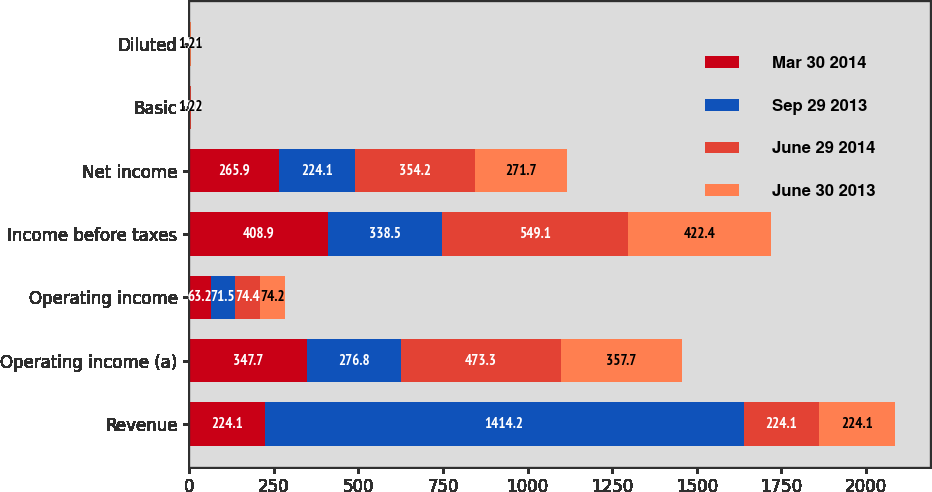<chart> <loc_0><loc_0><loc_500><loc_500><stacked_bar_chart><ecel><fcel>Revenue<fcel>Operating income (a)<fcel>Operating income<fcel>Income before taxes<fcel>Net income<fcel>Basic<fcel>Diluted<nl><fcel>Mar 30 2014<fcel>224.1<fcel>347.7<fcel>63.2<fcel>408.9<fcel>265.9<fcel>1.21<fcel>1.21<nl><fcel>Sep 29 2013<fcel>1414.2<fcel>276.8<fcel>71.5<fcel>338.5<fcel>224.1<fcel>1<fcel>0.99<nl><fcel>June 29 2014<fcel>224.1<fcel>473.3<fcel>74.4<fcel>549.1<fcel>354.2<fcel>1.63<fcel>1.62<nl><fcel>June 30 2013<fcel>224.1<fcel>357.7<fcel>74.2<fcel>422.4<fcel>271.7<fcel>1.22<fcel>1.21<nl></chart> 